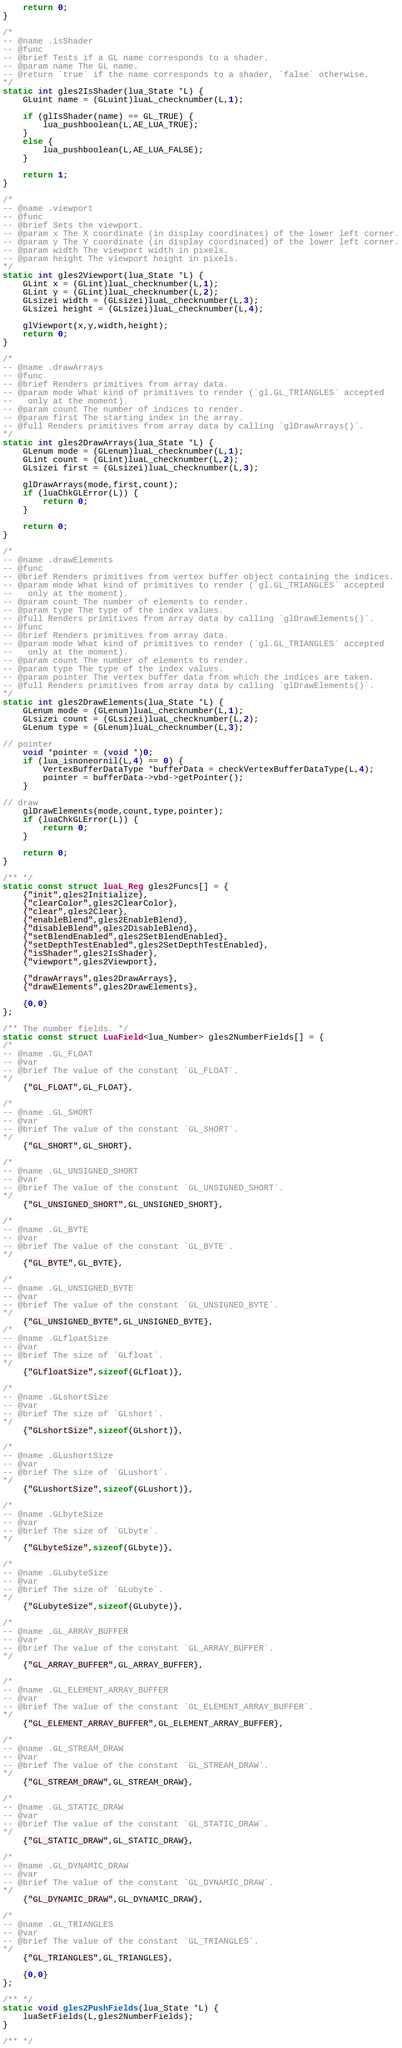<code> <loc_0><loc_0><loc_500><loc_500><_C++_>    return 0;    
}

/*
-- @name .isShader
-- @func
-- @brief Tests if a GL name corresponds to a shader.
-- @param name The GL name.
-- @return `true` if the name corresponds to a shader, `false` otherwise.
*/
static int gles2IsShader(lua_State *L) {
    GLuint name = (GLuint)luaL_checknumber(L,1);
    
    if (glIsShader(name) == GL_TRUE) {
        lua_pushboolean(L,AE_LUA_TRUE);
    }
    else {
        lua_pushboolean(L,AE_LUA_FALSE);
    }
    
    return 1;
}

/*
-- @name .viewport
-- @func
-- @brief Sets the viewport.
-- @param x The X coordinate (in display coordinates) of the lower left corner.
-- @param y The Y coordinate (in display coordinated) of the lower left corner.
-- @param width The viewport width in pixels.
-- @param height The viewport height in pixels.
*/
static int gles2Viewport(lua_State *L) {
    GLint x = (GLint)luaL_checknumber(L,1);
    GLint y = (GLint)luaL_checknumber(L,2);
    GLsizei width = (GLsizei)luaL_checknumber(L,3);
    GLsizei height = (GLsizei)luaL_checknumber(L,4);

    glViewport(x,y,width,height);
    return 0;
}

/*
-- @name .drawArrays
-- @func
-- @brief Renders primitives from array data.
-- @param mode What kind of primitives to render (`gl.GL_TRIANGLES` accepted
--   only at the moment).
-- @param count The number of indices to render.
-- @param first The starting index in the array.
-- @full Renders primitives from array data by calling `glDrawArrays()`.
*/
static int gles2DrawArrays(lua_State *L) {
    GLenum mode = (GLenum)luaL_checknumber(L,1);
    GLint count = (GLint)luaL_checknumber(L,2);    
    GLsizei first = (GLsizei)luaL_checknumber(L,3);
    
    glDrawArrays(mode,first,count);     
    if (luaChkGLError(L)) {
        return 0;
    }        
    
    return 0;    
}

/*
-- @name .drawElements
-- @func
-- @brief Renders primitives from vertex buffer object containing the indices.
-- @param mode What kind of primitives to render (`gl.GL_TRIANGLES` accepted
--   only at the moment).
-- @param count The number of elements to render.
-- @param type The type of the index values.
-- @full Renders primitives from array data by calling `glDrawElements()`.
-- @func
-- @brief Renders primitives from array data.
-- @param mode What kind of primitives to render (`gl.GL_TRIANGLES` accepted
--   only at the moment).
-- @param count The number of elements to render.
-- @param type The type of the index values.
-- @param pointer The vertex buffer data from which the indices are taken.
-- @full Renders primitives from array data by calling `glDrawElements()`.
*/
static int gles2DrawElements(lua_State *L) {
    GLenum mode = (GLenum)luaL_checknumber(L,1);
    GLsizei count = (GLsizei)luaL_checknumber(L,2);    
    GLenum type = (GLenum)luaL_checknumber(L,3);
    
// pointer
    void *pointer = (void *)0;
    if (lua_isnoneornil(L,4) == 0) {
        VertexBufferDataType *bufferData = checkVertexBufferDataType(L,4);
        pointer = bufferData->vbd->getPointer();
    }
    
// draw
    glDrawElements(mode,count,type,pointer);
    if (luaChkGLError(L)) {
        return 0;
    }
   
    return 0;
}

/** */
static const struct luaL_Reg gles2Funcs[] = {
    {"init",gles2Initialize},
    {"clearColor",gles2ClearColor},
    {"clear",gles2Clear},
    {"enableBlend",gles2EnableBlend},
    {"disableBlend",gles2DisableBlend},
    {"setBlendEnabled",gles2SetBlendEnabled},
    {"setDepthTestEnabled",gles2SetDepthTestEnabled},
    {"isShader",gles2IsShader},
    {"viewport",gles2Viewport},
    
    {"drawArrays",gles2DrawArrays},
    {"drawElements",gles2DrawElements},
    
    {0,0}
};

/** The number fields. */
static const struct LuaField<lua_Number> gles2NumberFields[] = {
/*
-- @name .GL_FLOAT
-- @var
-- @brief The value of the constant `GL_FLOAT`.
*/
    {"GL_FLOAT",GL_FLOAT},

/*
-- @name .GL_SHORT
-- @var
-- @brief The value of the constant `GL_SHORT`.
*/
    {"GL_SHORT",GL_SHORT},
    
/*
-- @name .GL_UNSIGNED_SHORT
-- @var
-- @brief The value of the constant `GL_UNSIGNED_SHORT`.
*/
    {"GL_UNSIGNED_SHORT",GL_UNSIGNED_SHORT},

/*
-- @name .GL_BYTE
-- @var
-- @brief The value of the constant `GL_BYTE`.
*/
    {"GL_BYTE",GL_BYTE},
    
/*
-- @name .GL_UNSIGNED_BYTE
-- @var
-- @brief The value of the constant `GL_UNSIGNED_BYTE`.
*/
    {"GL_UNSIGNED_BYTE",GL_UNSIGNED_BYTE},
/*
-- @name .GLfloatSize
-- @var
-- @brief The size of `GLfloat`.
*/
    {"GLfloatSize",sizeof(GLfloat)},
    
/*
-- @name .GLshortSize
-- @var
-- @brief The size of `GLshort`.
*/
    {"GLshortSize",sizeof(GLshort)},
    
/*
-- @name .GLushortSize
-- @var
-- @brief The size of `GLushort`.
*/
    {"GLushortSize",sizeof(GLushort)},
    
/*
-- @name .GLbyteSize
-- @var
-- @brief The size of `GLbyte`.
*/
    {"GLbyteSize",sizeof(GLbyte)},
    
/*
-- @name .GLubyteSize
-- @var
-- @brief The size of `GLubyte`.
*/
    {"GLubyteSize",sizeof(GLubyte)},
    
/*
-- @name .GL_ARRAY_BUFFER
-- @var
-- @brief The value of the constant `GL_ARRAY_BUFFER`.
*/
    {"GL_ARRAY_BUFFER",GL_ARRAY_BUFFER},
    
/*
-- @name .GL_ELEMENT_ARRAY_BUFFER
-- @var
-- @brief The value of the constant `GL_ELEMENT_ARRAY_BUFFER`.
*/
    {"GL_ELEMENT_ARRAY_BUFFER",GL_ELEMENT_ARRAY_BUFFER},
        
/*
-- @name .GL_STREAM_DRAW 
-- @var
-- @brief The value of the constant `GL_STREAM_DRAW`.
*/
    {"GL_STREAM_DRAW",GL_STREAM_DRAW},
    
/*
-- @name .GL_STATIC_DRAW
-- @var
-- @brief The value of the constant `GL_STATIC_DRAW`.
*/
    {"GL_STATIC_DRAW",GL_STATIC_DRAW},
    
/*
-- @name .GL_DYNAMIC_DRAW
-- @var
-- @brief The value of the constant `GL_DYNAMIC_DRAW`.
*/
    {"GL_DYNAMIC_DRAW",GL_DYNAMIC_DRAW},
        
/*
-- @name .GL_TRIANGLES
-- @var
-- @brief The value of the constant `GL_TRIANGLES`.
*/
    {"GL_TRIANGLES",GL_TRIANGLES},
    
    {0,0} 
};
 
/** */
static void gles2PushFields(lua_State *L) {
    luaSetFields(L,gles2NumberFields);
}

/** */</code> 